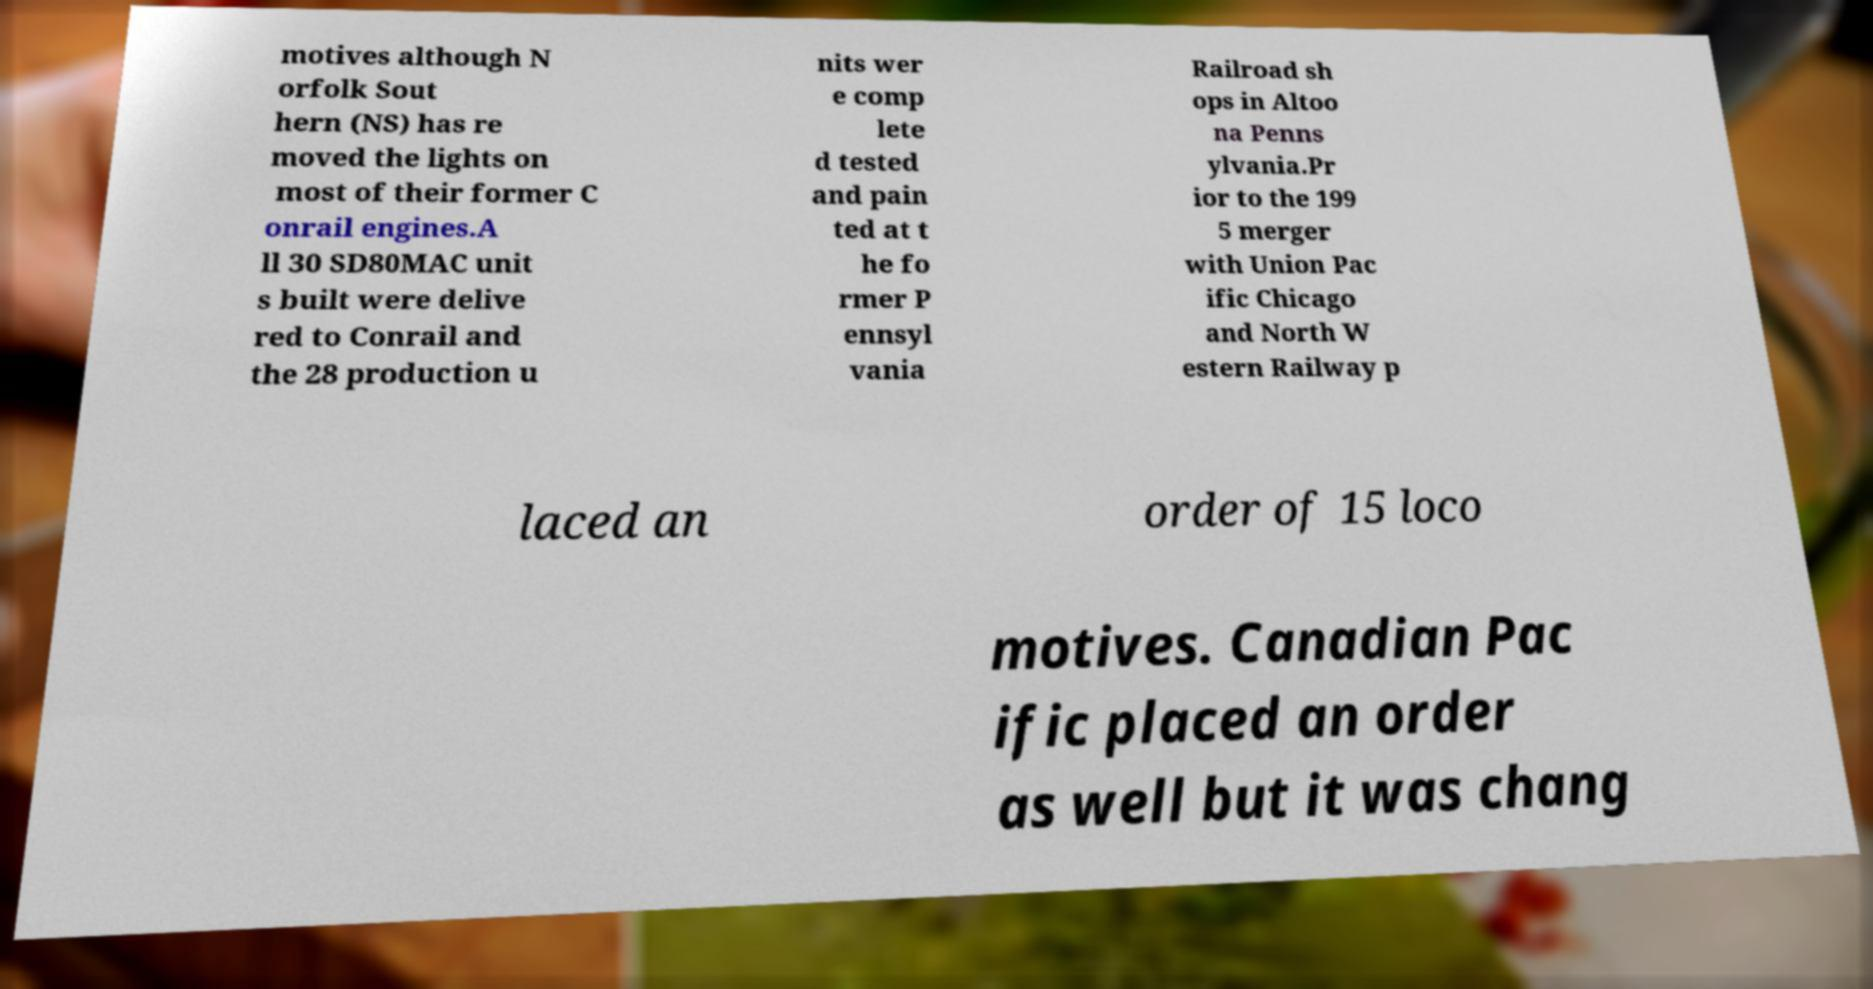Please read and relay the text visible in this image. What does it say? motives although N orfolk Sout hern (NS) has re moved the lights on most of their former C onrail engines.A ll 30 SD80MAC unit s built were delive red to Conrail and the 28 production u nits wer e comp lete d tested and pain ted at t he fo rmer P ennsyl vania Railroad sh ops in Altoo na Penns ylvania.Pr ior to the 199 5 merger with Union Pac ific Chicago and North W estern Railway p laced an order of 15 loco motives. Canadian Pac ific placed an order as well but it was chang 